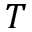Convert formula to latex. <formula><loc_0><loc_0><loc_500><loc_500>T</formula> 